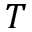Convert formula to latex. <formula><loc_0><loc_0><loc_500><loc_500>T</formula> 